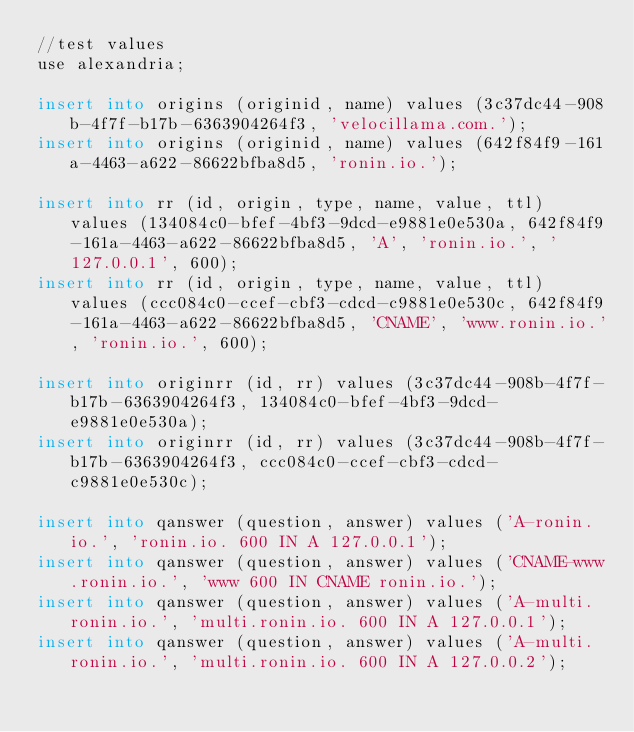Convert code to text. <code><loc_0><loc_0><loc_500><loc_500><_SQL_>//test values
use alexandria;

insert into origins (originid, name) values (3c37dc44-908b-4f7f-b17b-6363904264f3, 'velocillama.com.');
insert into origins (originid, name) values (642f84f9-161a-4463-a622-86622bfba8d5, 'ronin.io.');

insert into rr (id, origin, type, name, value, ttl) values (134084c0-bfef-4bf3-9dcd-e9881e0e530a, 642f84f9-161a-4463-a622-86622bfba8d5, 'A', 'ronin.io.', '127.0.0.1', 600);
insert into rr (id, origin, type, name, value, ttl) values (ccc084c0-ccef-cbf3-cdcd-c9881e0e530c, 642f84f9-161a-4463-a622-86622bfba8d5, 'CNAME', 'www.ronin.io.', 'ronin.io.', 600);

insert into originrr (id, rr) values (3c37dc44-908b-4f7f-b17b-6363904264f3, 134084c0-bfef-4bf3-9dcd-e9881e0e530a);
insert into originrr (id, rr) values (3c37dc44-908b-4f7f-b17b-6363904264f3, ccc084c0-ccef-cbf3-cdcd-c9881e0e530c);

insert into qanswer (question, answer) values ('A-ronin.io.', 'ronin.io. 600 IN A 127.0.0.1');
insert into qanswer (question, answer) values ('CNAME-www.ronin.io.', 'www 600 IN CNAME ronin.io.');
insert into qanswer (question, answer) values ('A-multi.ronin.io.', 'multi.ronin.io. 600 IN A 127.0.0.1');
insert into qanswer (question, answer) values ('A-multi.ronin.io.', 'multi.ronin.io. 600 IN A 127.0.0.2');
</code> 